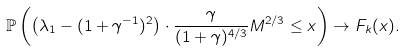<formula> <loc_0><loc_0><loc_500><loc_500>\mathbb { P } \left ( \left ( \lambda _ { 1 } - ( 1 + \gamma ^ { - 1 } ) ^ { 2 } \right ) \cdot \frac { \gamma } { ( 1 + \gamma ) ^ { 4 / 3 } } M ^ { 2 / 3 } \leq x \right ) \to F _ { k } ( x ) .</formula> 